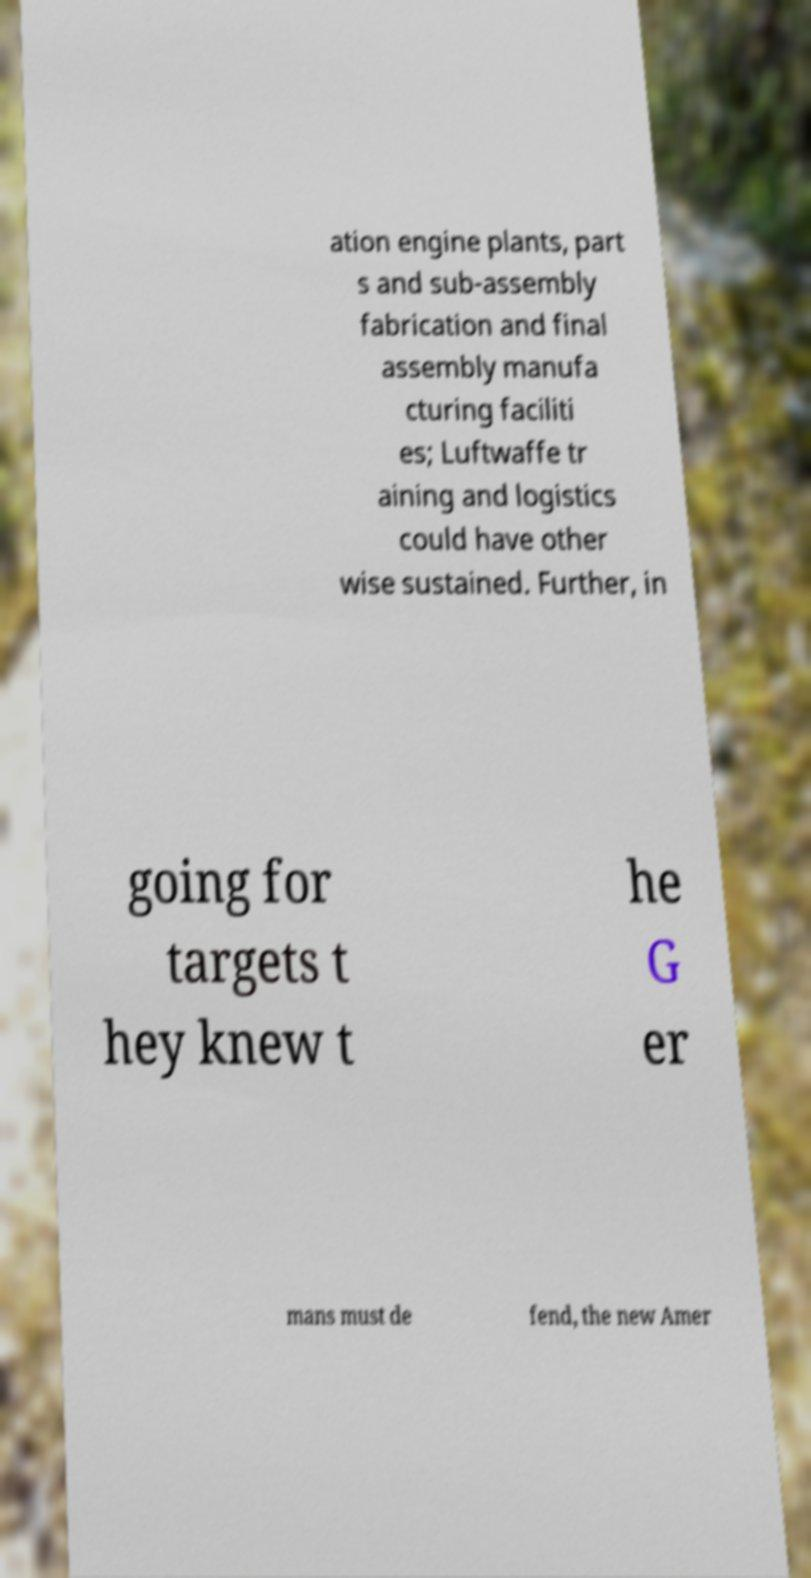Please read and relay the text visible in this image. What does it say? ation engine plants, part s and sub-assembly fabrication and final assembly manufa cturing faciliti es; Luftwaffe tr aining and logistics could have other wise sustained. Further, in going for targets t hey knew t he G er mans must de fend, the new Amer 